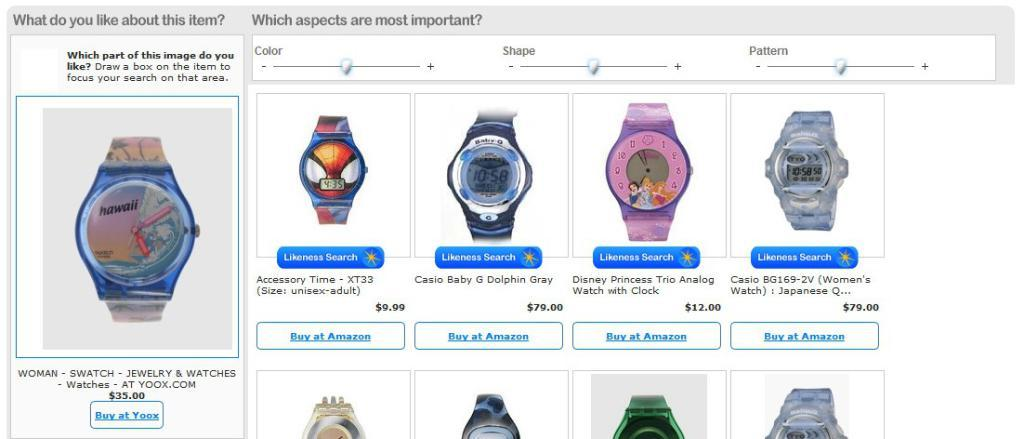<image>
Provide a brief description of the given image. A picture of watches and a question asking which part of the image do you like. 